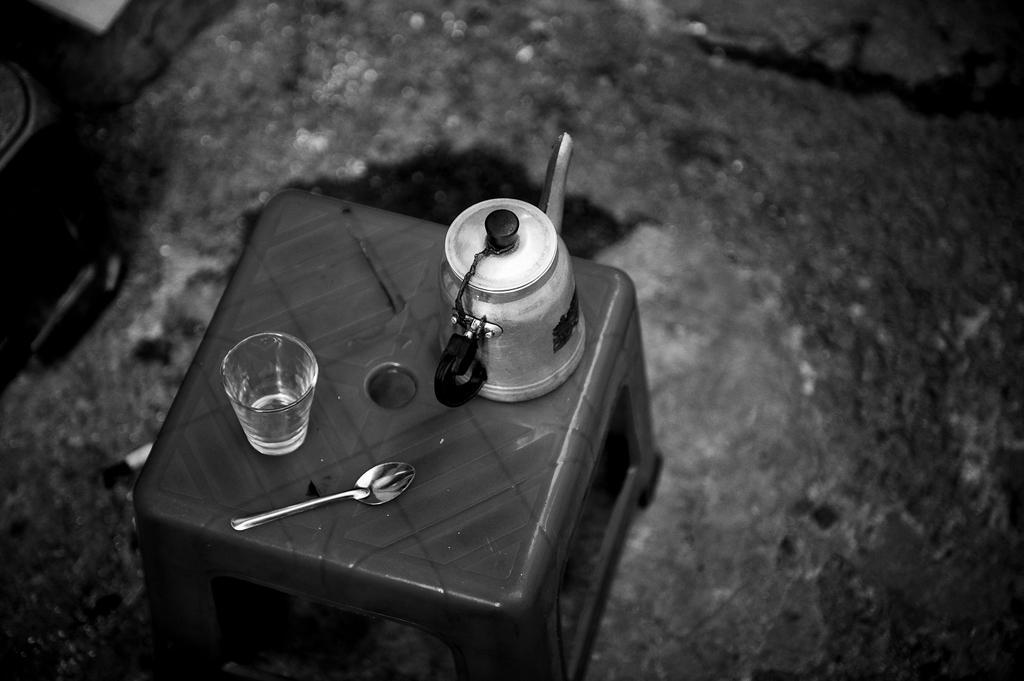Could you give a brief overview of what you see in this image? In this image we can see a teapot, glass and a spoon on a stool. Beside the tool we can see the ground. 